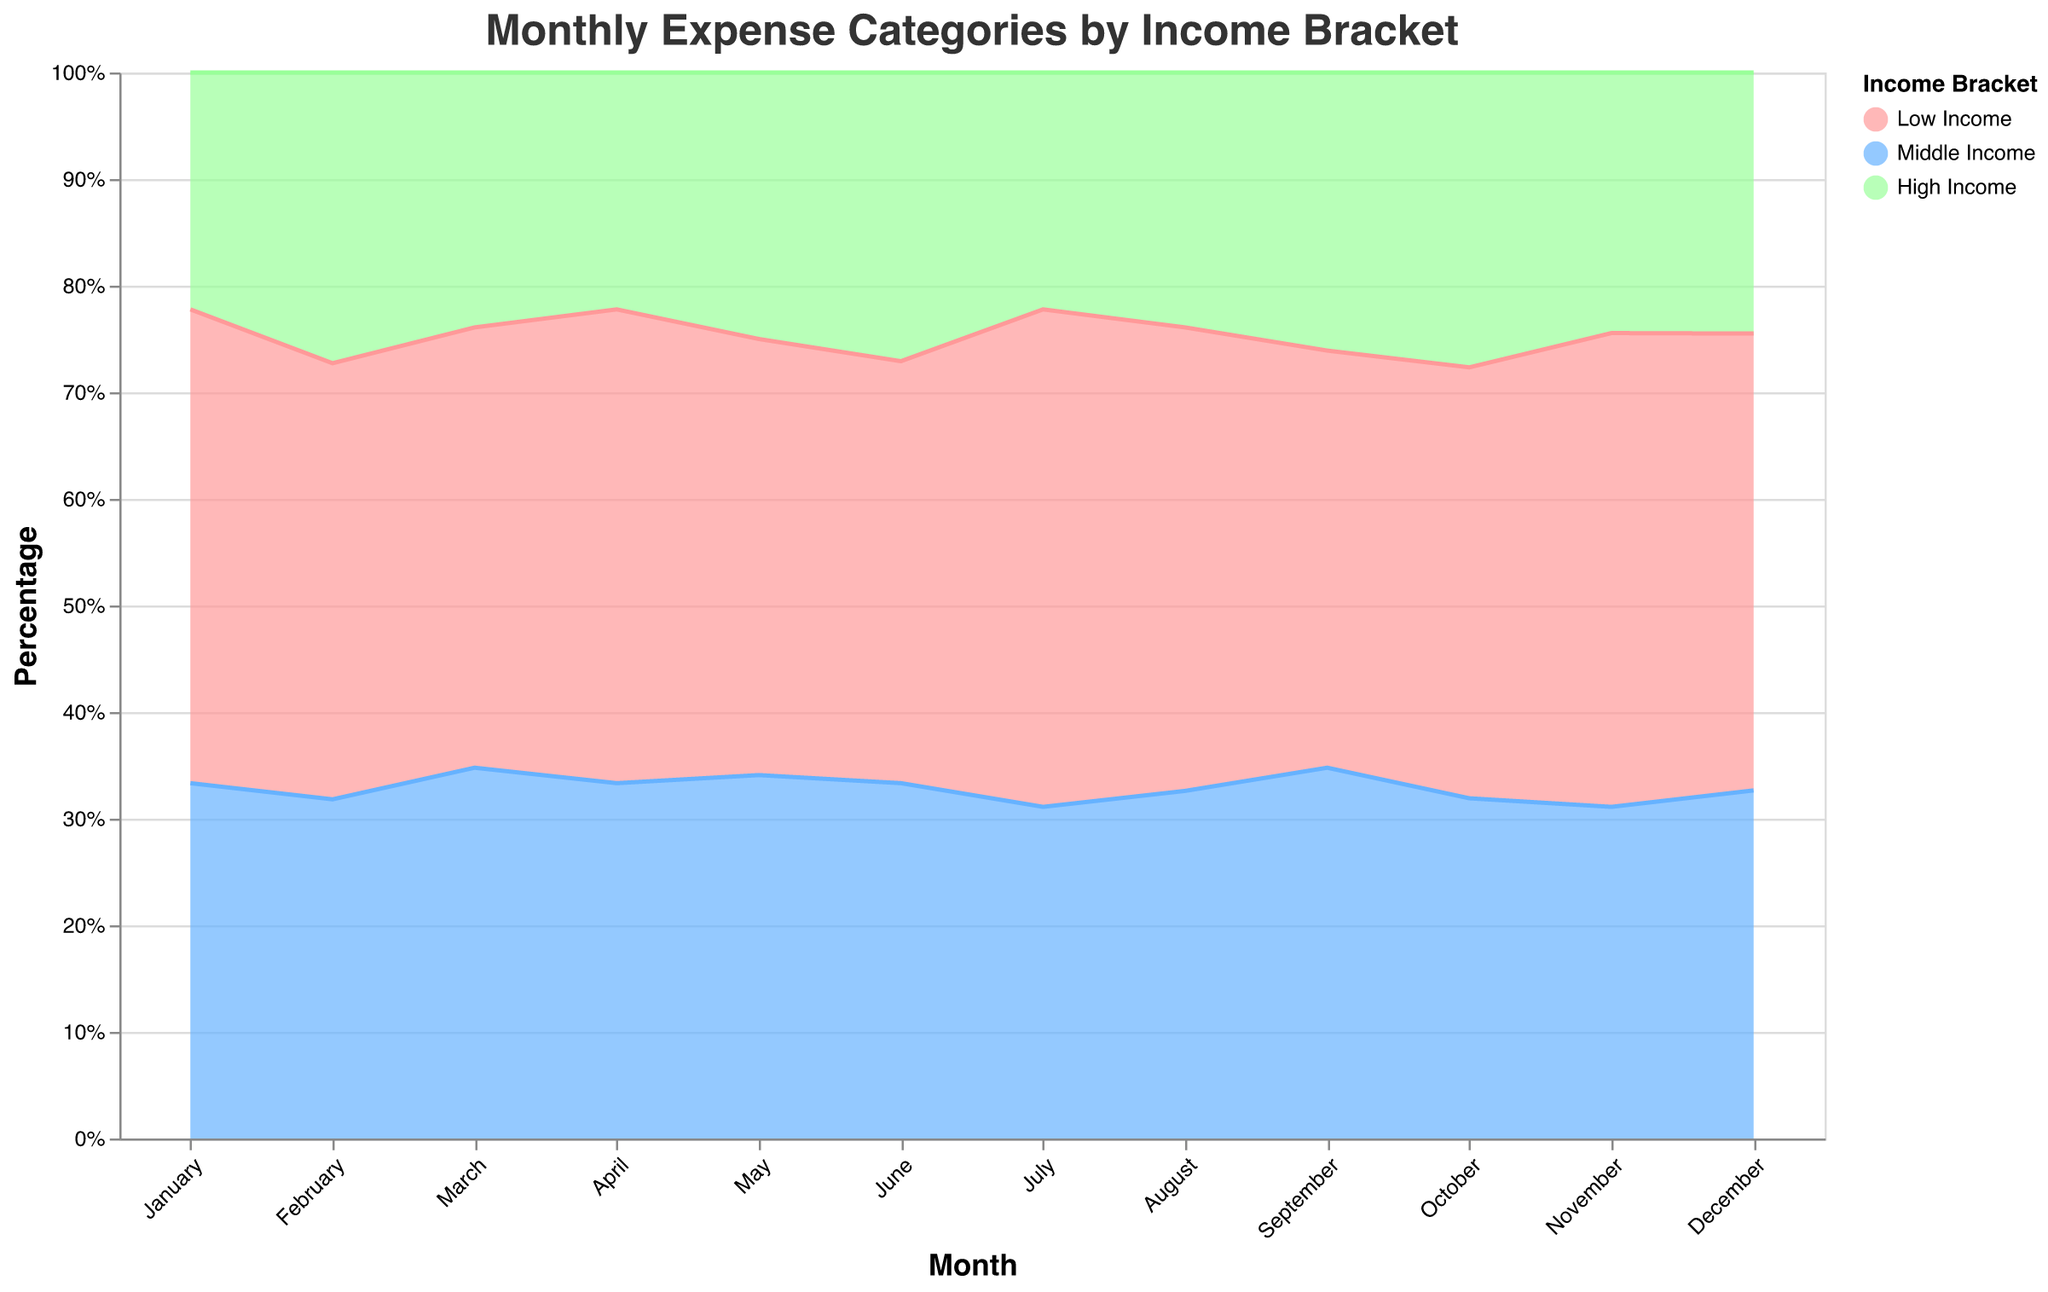What is the title of the figure? The title of the figure is specified at the top and it reads "Monthly Expense Categories by Income Bracket".
Answer: Monthly Expense Categories by Income Bracket Which category consistently takes up a significant portion of the expenses across all income brackets? By examining the 100% stacked area chart, you can see that the category "Rent/Mortgage" frequently occupies a large portion of the area across different months and income brackets.
Answer: Rent/Mortgage In which month does the High Income bracket have the highest percentage for Food & Groceries? Referring to the figure, the highest relative percentage of "Food & Groceries" for the High Income bracket appears in July, where the area for this category is highest.
Answer: July What are the color representations for the different income brackets? In the legend, "Low Income" is represented by pink, "Middle Income" by blue, and "High Income" by green. These colors appear consistently throughout the figure.
Answer: Pink (Low Income), Blue (Middle Income), Green (High Income) Which income bracket has the highest savings percentage, and in which month is this observed? Analyzing the stacked areas, the High Income bracket has the highest percentage for "Savings" throughout the months, peaking specifically in December.
Answer: High Income, December How does the expenditure on healthcare compare between Low Income and High Income brackets in February? By comparing the area sections for "Healthcare" in February, the Low Income bracket has a slightly larger section for healthcare compared to the High Income bracket.
Answer: Low Income spends more What changes can you observe in the "Entertainment" category across months for the Middle Income bracket? Observing the Middle Income bracket's section for "Entertainment" over different months, it fluctuates with some increases and decreases but does not show a consistent increasing or decreasing trend overall.
Answer: Fluctuates without a consistent trend In which month and for which income bracket is the expenditure on "Utilities" the lowest? Checking the smaller sections of "Utilities" across the months for the different income brackets, the High Income bracket shows the lowest expenditure on utilities in July.
Answer: High Income, July Which income bracket has the smallest relative expenditure on "Education" in November? Comparing the areas allocated to "Education" for November, the Low Income bracket has the smallest relative expenditure on this category.
Answer: Low Income 